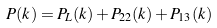<formula> <loc_0><loc_0><loc_500><loc_500>P ( k ) = P _ { L } ( k ) + P _ { 2 2 } ( k ) + P _ { 1 3 } ( k )</formula> 